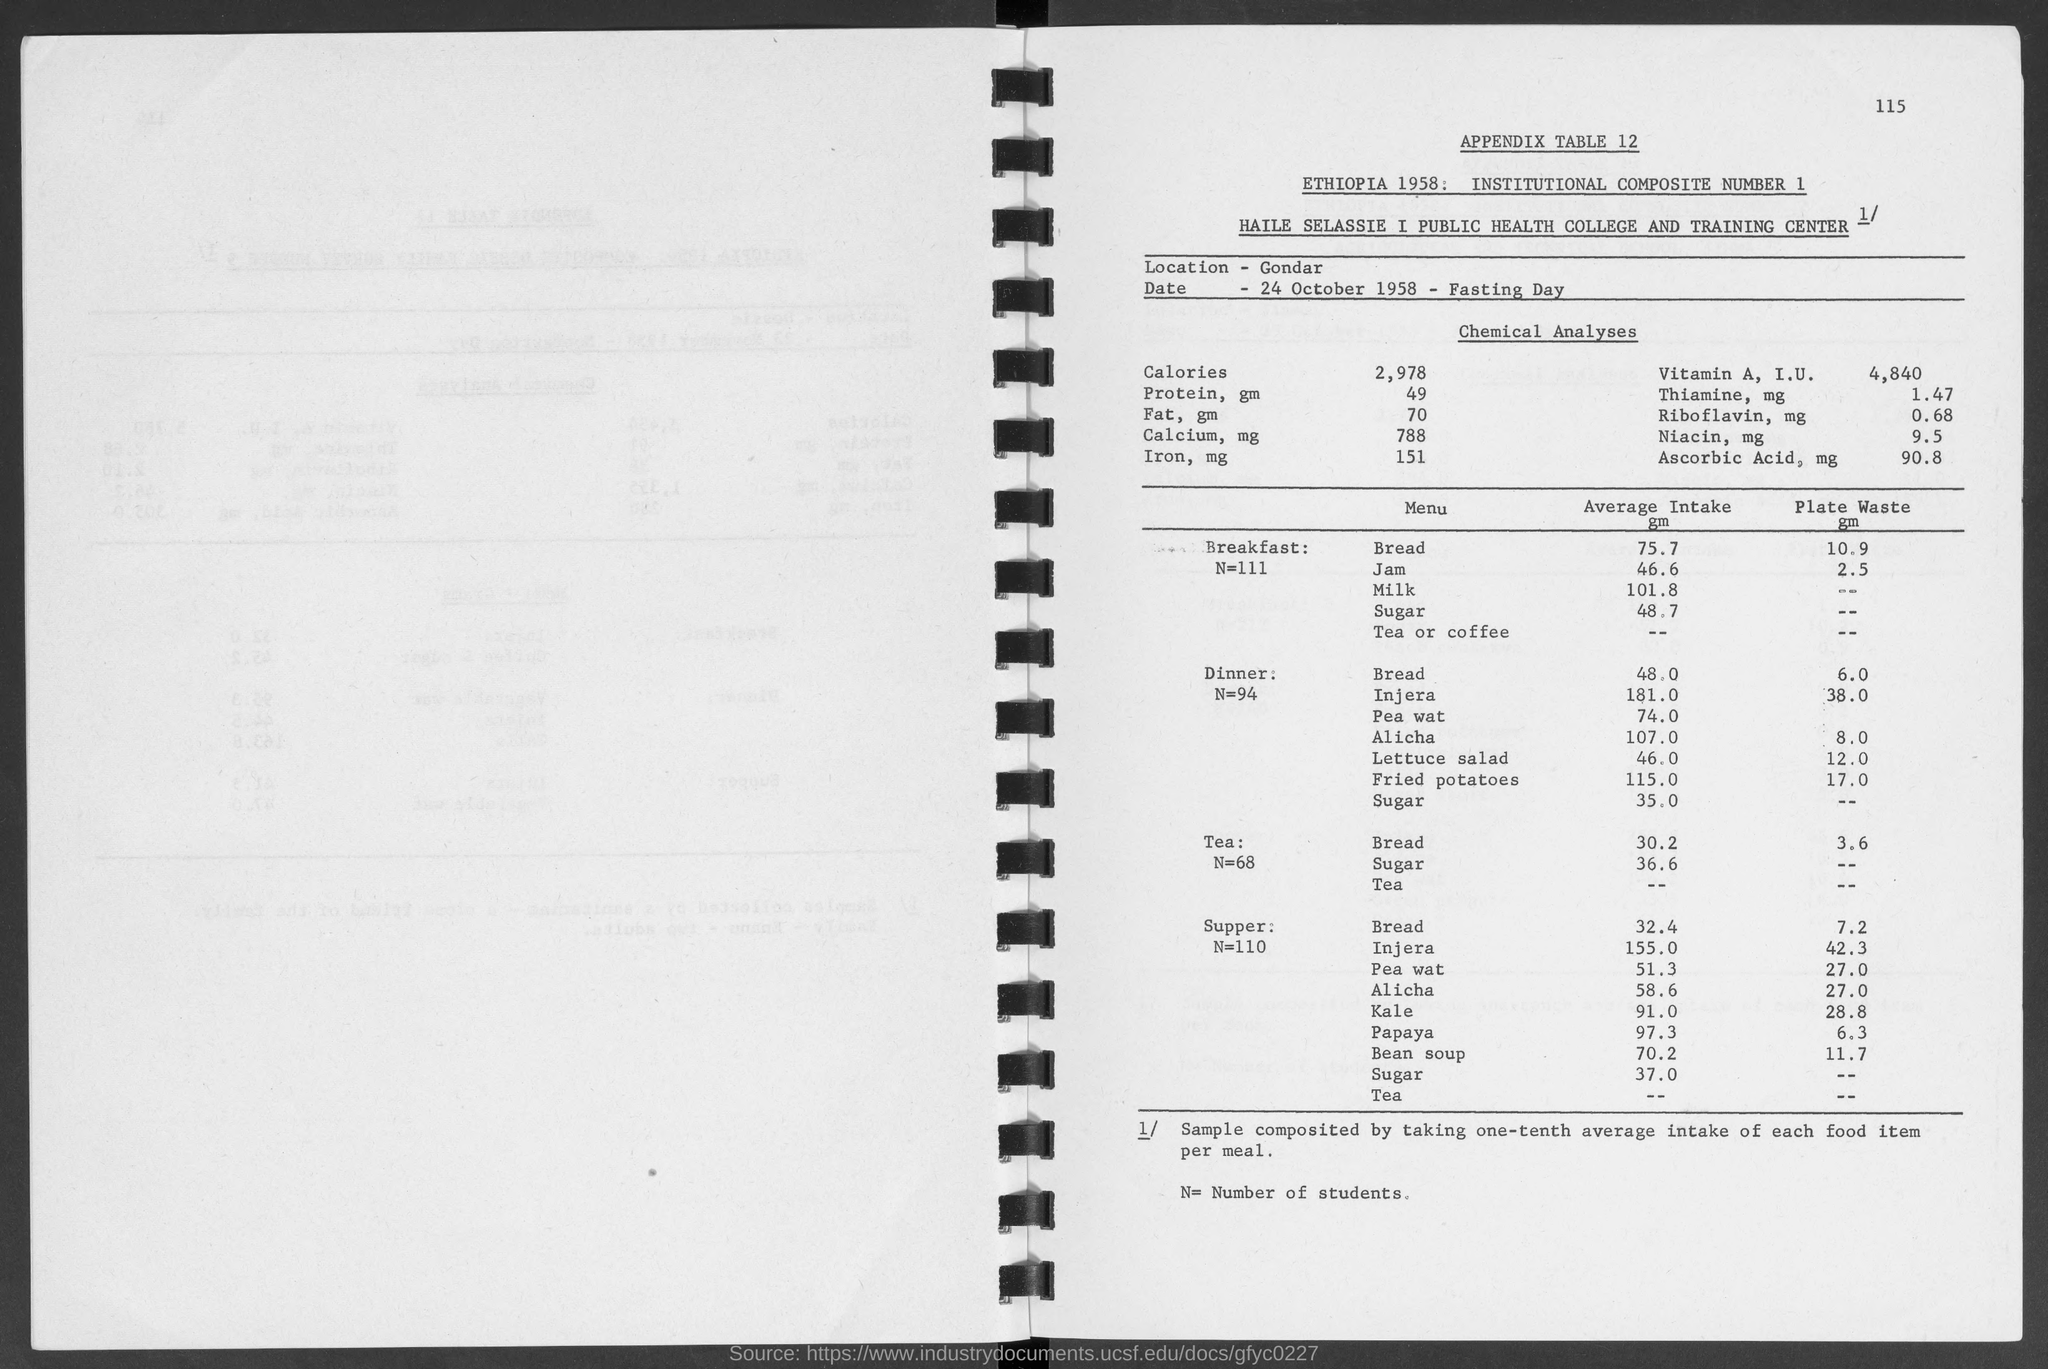What is the number at top-right corner of the page?
Make the answer very short. 115. What is the location?
Your answer should be very brief. Gondar. What is the date below location ?
Keep it short and to the point. 24 October 1958 - Fasting Day. What is the appendix table no.?
Offer a very short reply. 12. What is the average intake of bread in breakfast ?
Give a very brief answer. 75.7 gm. What is the average intake of jam in breakfast ?
Offer a terse response. 46.6. What is the average of milk in breakfast ?
Ensure brevity in your answer.  101.8. What is the average intake of sugar in breakfast?
Give a very brief answer. 48.7 gm. What is the average intake of sugar in dinner ?
Provide a succinct answer. 35.0 gm. What is the average intake of bread in dinner ?
Your response must be concise. 48.0. 